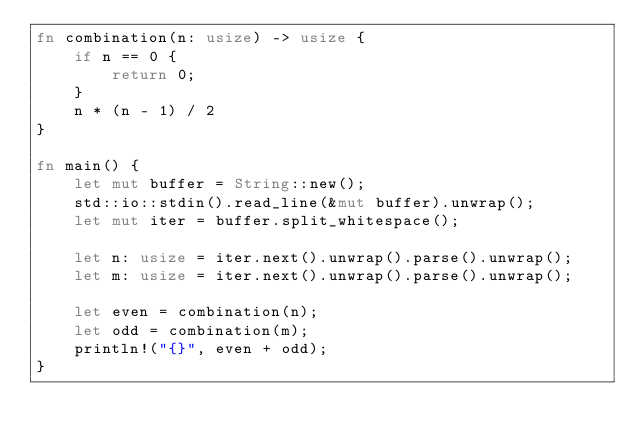<code> <loc_0><loc_0><loc_500><loc_500><_Rust_>fn combination(n: usize) -> usize {
    if n == 0 {
        return 0;
    }
    n * (n - 1) / 2
}

fn main() {
    let mut buffer = String::new();
    std::io::stdin().read_line(&mut buffer).unwrap();
    let mut iter = buffer.split_whitespace();

    let n: usize = iter.next().unwrap().parse().unwrap();
    let m: usize = iter.next().unwrap().parse().unwrap();

    let even = combination(n);
    let odd = combination(m);
    println!("{}", even + odd);
}</code> 